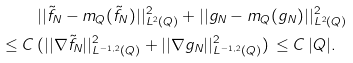<formula> <loc_0><loc_0><loc_500><loc_500>& | | \tilde { f } _ { N } - m _ { Q } ( \tilde { f } _ { N } ) | | ^ { 2 } _ { L ^ { 2 } ( Q ) } + | | g _ { N } - m _ { Q } ( g _ { N } ) | | ^ { 2 } _ { L ^ { 2 } ( Q ) } \\ \leq C \, & ( | | \nabla \tilde { f } _ { N } | | ^ { 2 } _ { L ^ { - 1 , \, 2 } ( Q ) } + | | \nabla g _ { N } | | ^ { 2 } _ { L ^ { - 1 , \, 2 } ( Q ) } ) \, \leq C \, | Q | .</formula> 